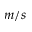<formula> <loc_0><loc_0><loc_500><loc_500>m / s</formula> 